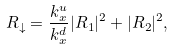Convert formula to latex. <formula><loc_0><loc_0><loc_500><loc_500>R _ { \downarrow } = \frac { k _ { x } ^ { u } } { k _ { x } ^ { d } } | R _ { 1 } | ^ { 2 } + | R _ { 2 } | ^ { 2 } ,</formula> 